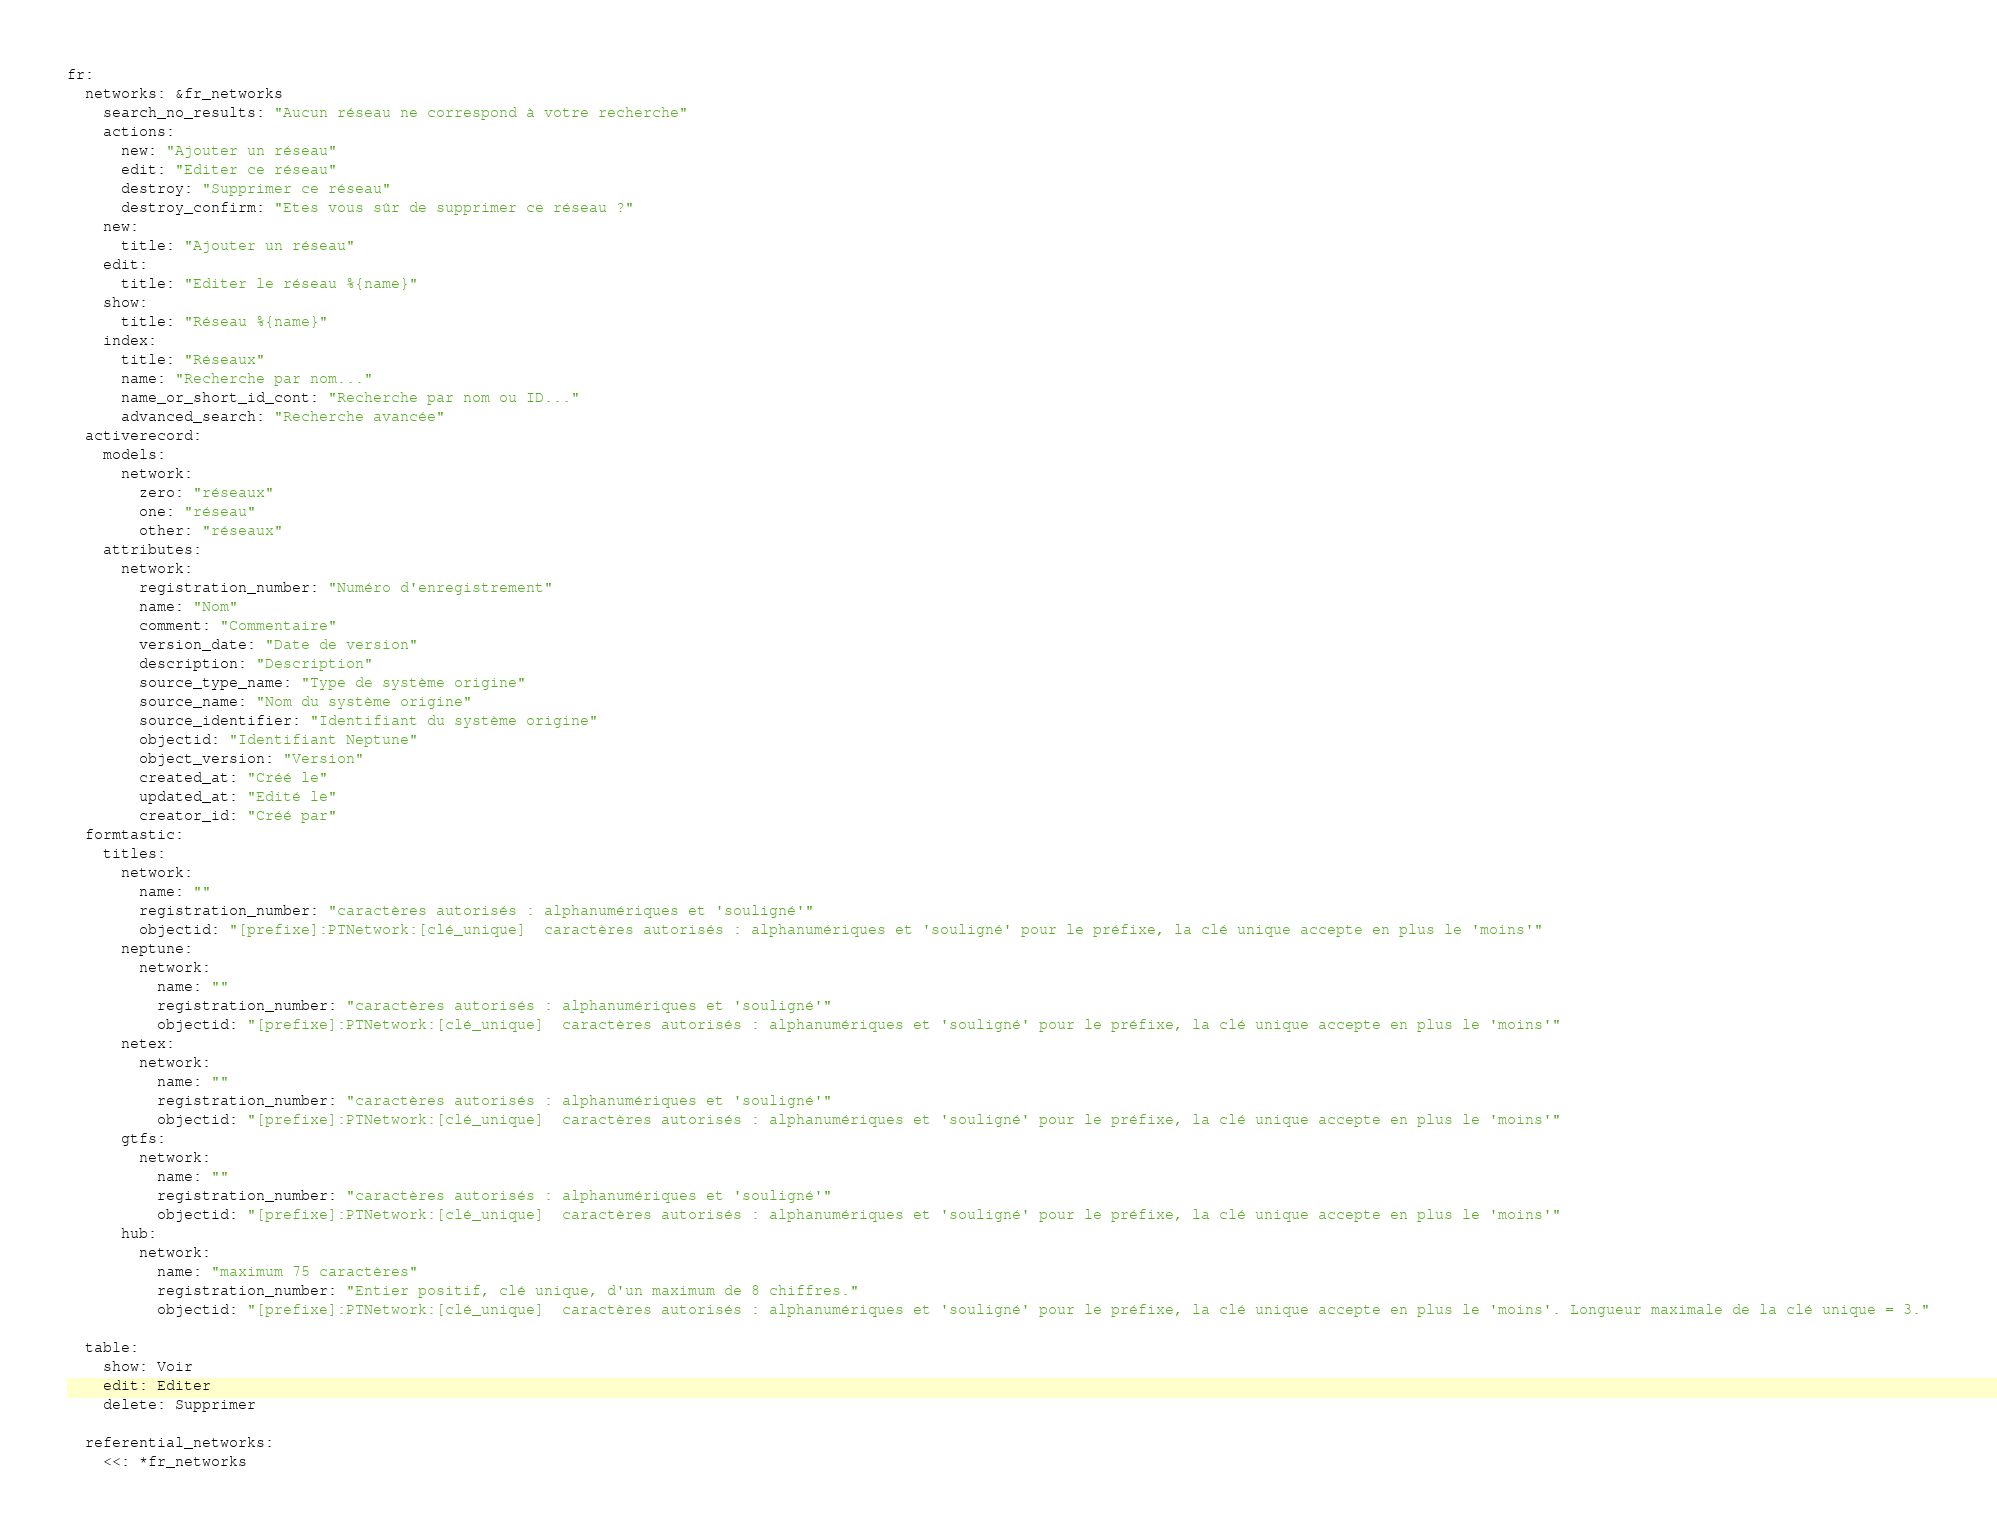Convert code to text. <code><loc_0><loc_0><loc_500><loc_500><_YAML_>fr:
  networks: &fr_networks
    search_no_results: "Aucun réseau ne correspond à votre recherche"
    actions:
      new: "Ajouter un réseau"
      edit: "Editer ce réseau"
      destroy: "Supprimer ce réseau"
      destroy_confirm: "Etes vous sûr de supprimer ce réseau ?"
    new:
      title: "Ajouter un réseau"
    edit:
      title: "Editer le réseau %{name}"
    show:
      title: "Réseau %{name}"
    index:
      title: "Réseaux"
      name: "Recherche par nom..."
      name_or_short_id_cont: "Recherche par nom ou ID..."
      advanced_search: "Recherche avancée"
  activerecord:
    models:
      network:
        zero: "réseaux"
        one: "réseau"
        other: "réseaux"
    attributes:
      network:
        registration_number: "Numéro d'enregistrement"
        name: "Nom"
        comment: "Commentaire"
        version_date: "Date de version"
        description: "Description"
        source_type_name: "Type de système origine"
        source_name: "Nom du système origine"
        source_identifier: "Identifiant du système origine"
        objectid: "Identifiant Neptune"
        object_version: "Version"
        created_at: "Créé le"
        updated_at: "Edité le"
        creator_id: "Créé par"
  formtastic:
    titles:
      network:
        name: ""
        registration_number: "caractères autorisés : alphanumériques et 'souligné'"
        objectid: "[prefixe]:PTNetwork:[clé_unique]  caractères autorisés : alphanumériques et 'souligné' pour le préfixe, la clé unique accepte en plus le 'moins'"
      neptune:
        network:
          name: ""
          registration_number: "caractères autorisés : alphanumériques et 'souligné'"
          objectid: "[prefixe]:PTNetwork:[clé_unique]  caractères autorisés : alphanumériques et 'souligné' pour le préfixe, la clé unique accepte en plus le 'moins'"
      netex:
        network:
          name: ""
          registration_number: "caractères autorisés : alphanumériques et 'souligné'"
          objectid: "[prefixe]:PTNetwork:[clé_unique]  caractères autorisés : alphanumériques et 'souligné' pour le préfixe, la clé unique accepte en plus le 'moins'"
      gtfs:
        network:
          name: ""
          registration_number: "caractères autorisés : alphanumériques et 'souligné'"
          objectid: "[prefixe]:PTNetwork:[clé_unique]  caractères autorisés : alphanumériques et 'souligné' pour le préfixe, la clé unique accepte en plus le 'moins'"
      hub:
        network:
          name: "maximum 75 caractères"
          registration_number: "Entier positif, clé unique, d'un maximum de 8 chiffres."
          objectid: "[prefixe]:PTNetwork:[clé_unique]  caractères autorisés : alphanumériques et 'souligné' pour le préfixe, la clé unique accepte en plus le 'moins'. Longueur maximale de la clé unique = 3."

  table:
    show: Voir
    edit: Editer
    delete: Supprimer

  referential_networks:
    <<: *fr_networks
</code> 